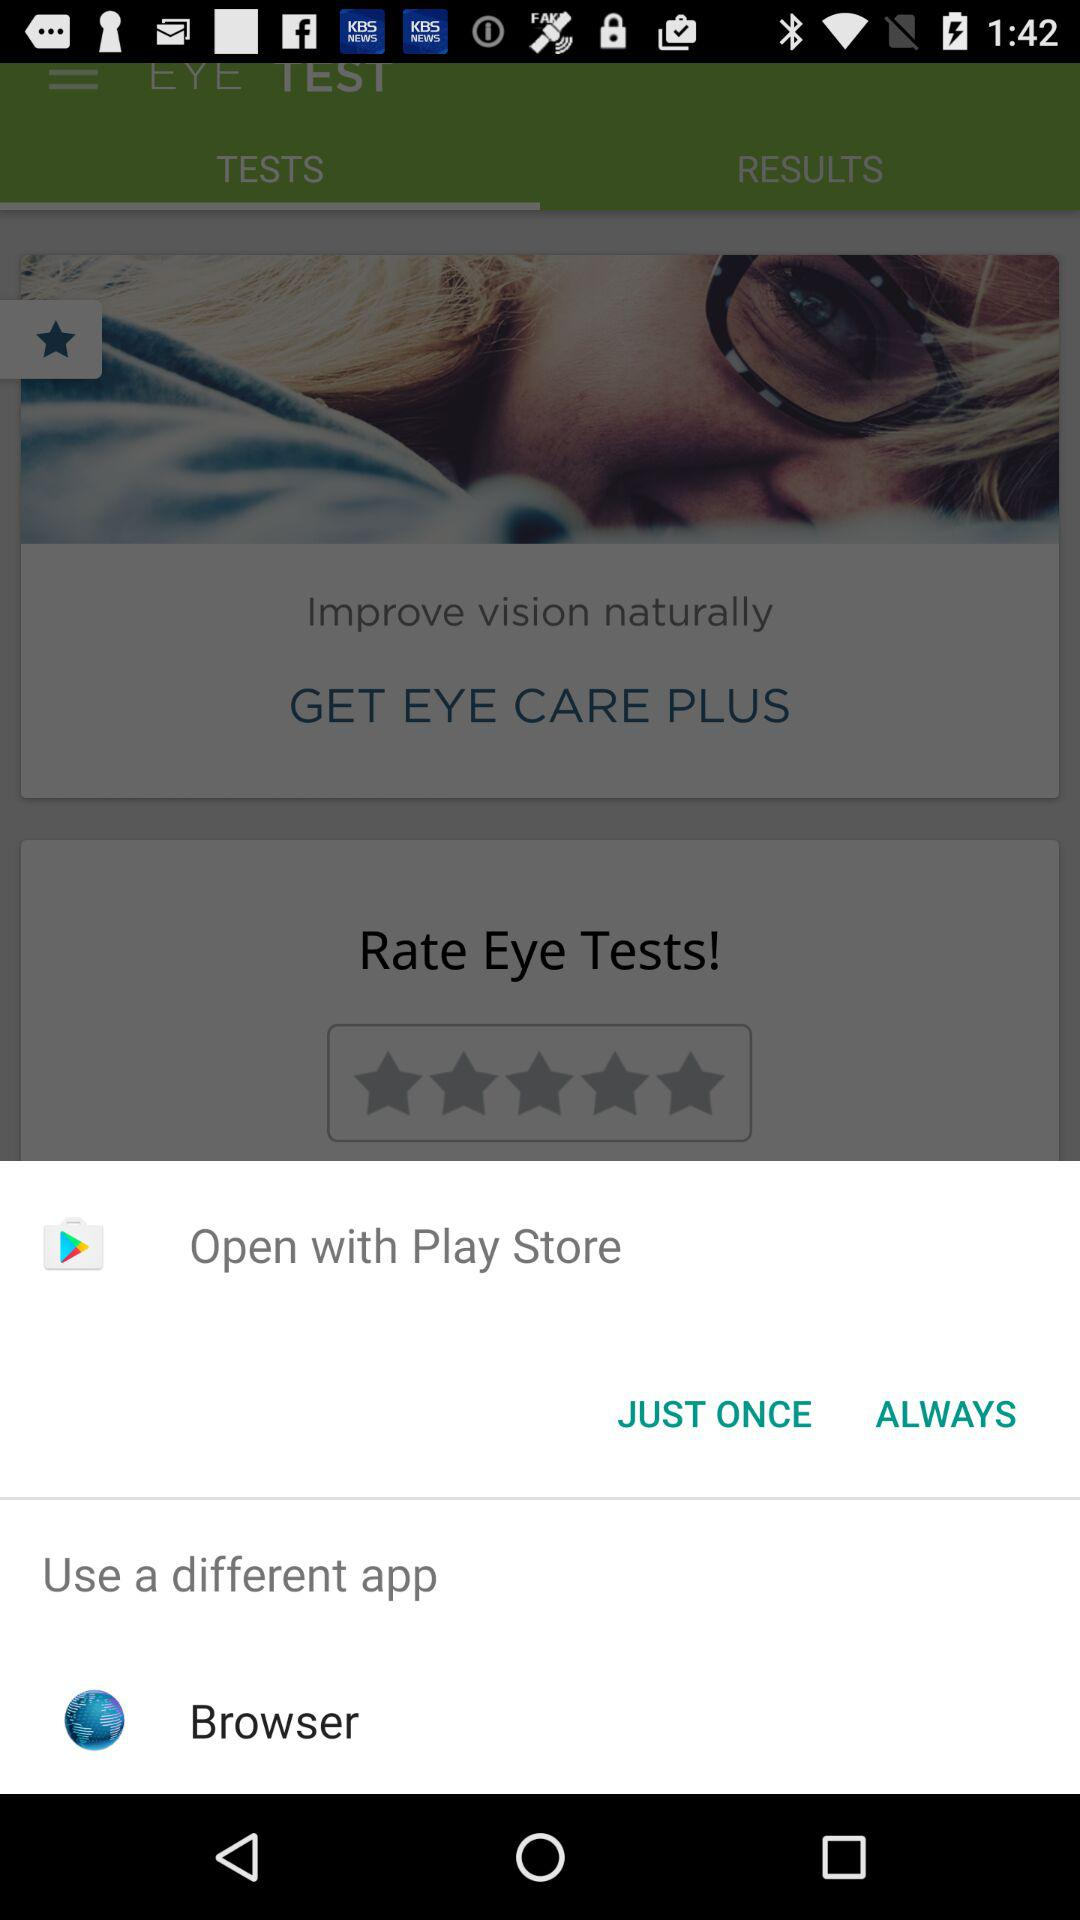What applications can be used to open the content? The application that can be used to open the content is "Play Store". 